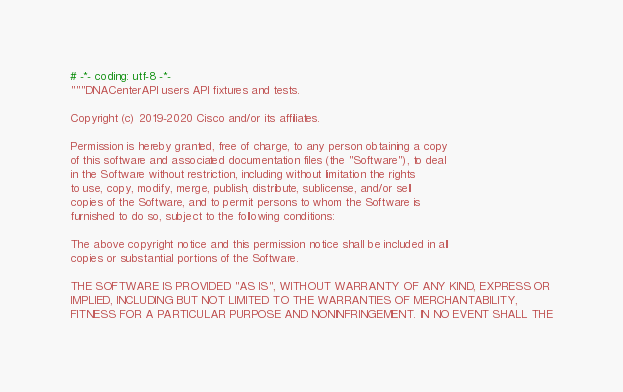Convert code to text. <code><loc_0><loc_0><loc_500><loc_500><_Python_># -*- coding: utf-8 -*-
"""DNACenterAPI users API fixtures and tests.

Copyright (c) 2019-2020 Cisco and/or its affiliates.

Permission is hereby granted, free of charge, to any person obtaining a copy
of this software and associated documentation files (the "Software"), to deal
in the Software without restriction, including without limitation the rights
to use, copy, modify, merge, publish, distribute, sublicense, and/or sell
copies of the Software, and to permit persons to whom the Software is
furnished to do so, subject to the following conditions:

The above copyright notice and this permission notice shall be included in all
copies or substantial portions of the Software.

THE SOFTWARE IS PROVIDED "AS IS", WITHOUT WARRANTY OF ANY KIND, EXPRESS OR
IMPLIED, INCLUDING BUT NOT LIMITED TO THE WARRANTIES OF MERCHANTABILITY,
FITNESS FOR A PARTICULAR PURPOSE AND NONINFRINGEMENT. IN NO EVENT SHALL THE</code> 